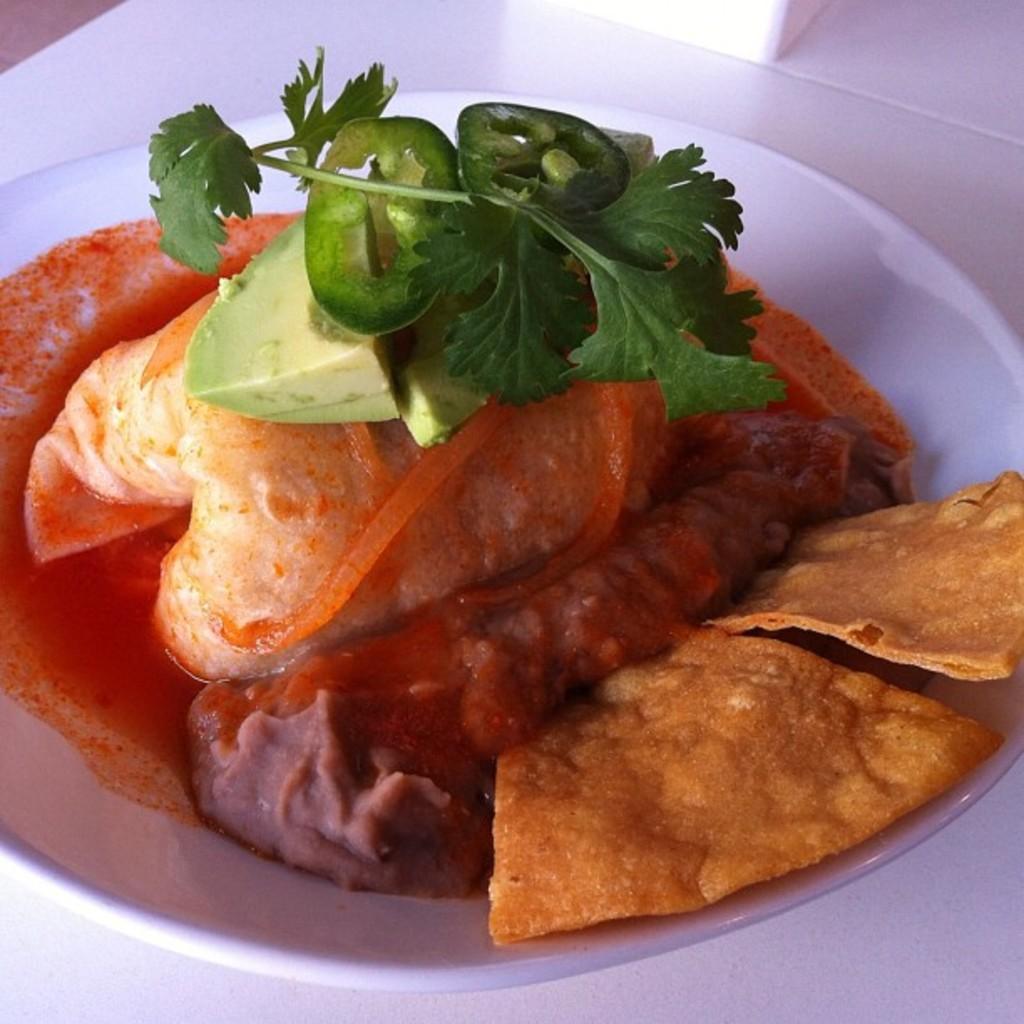How would you summarize this image in a sentence or two? In this image I can see the plate with food. I can see the plate is in white color and the food is in green, red and brown color. The plate is on the white color surface. 